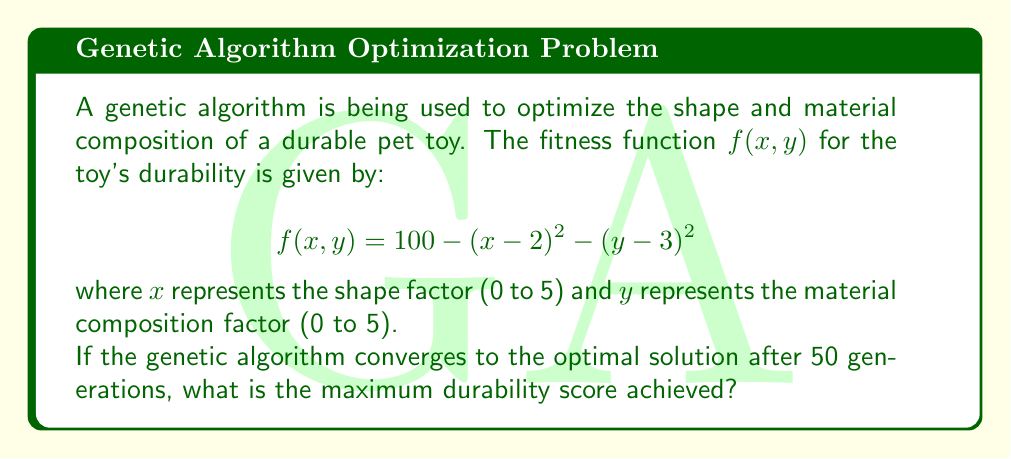Can you solve this math problem? To find the maximum durability score, we need to determine the optimal values of $x$ and $y$ that maximize the fitness function $f(x, y)$. Here's how we can solve this step-by-step:

1) The fitness function is given as:
   $$f(x, y) = 100 - (x - 2)^2 - (y - 3)^2$$

2) This function represents an inverted paraboloid with its maximum at the point where both squared terms are zero.

3) For the first term to be zero:
   $$(x - 2)^2 = 0$$
   $$x - 2 = 0$$
   $$x = 2$$

4) For the second term to be zero:
   $$(y - 3)^2 = 0$$
   $$y - 3 = 0$$
   $$y = 3$$

5) Therefore, the maximum of the function occurs at the point (2, 3).

6) To find the maximum durability score, we substitute these values back into the original function:

   $$f(2, 3) = 100 - (2 - 2)^2 - (3 - 3)^2$$
   $$= 100 - 0^2 - 0^2$$
   $$= 100 - 0 - 0$$
   $$= 100$$

7) Thus, the maximum durability score achieved is 100.

Note: The genetic algorithm would converge to this solution or a very close approximation after 50 generations, assuming it's well-designed and the problem space is well-explored.
Answer: 100 